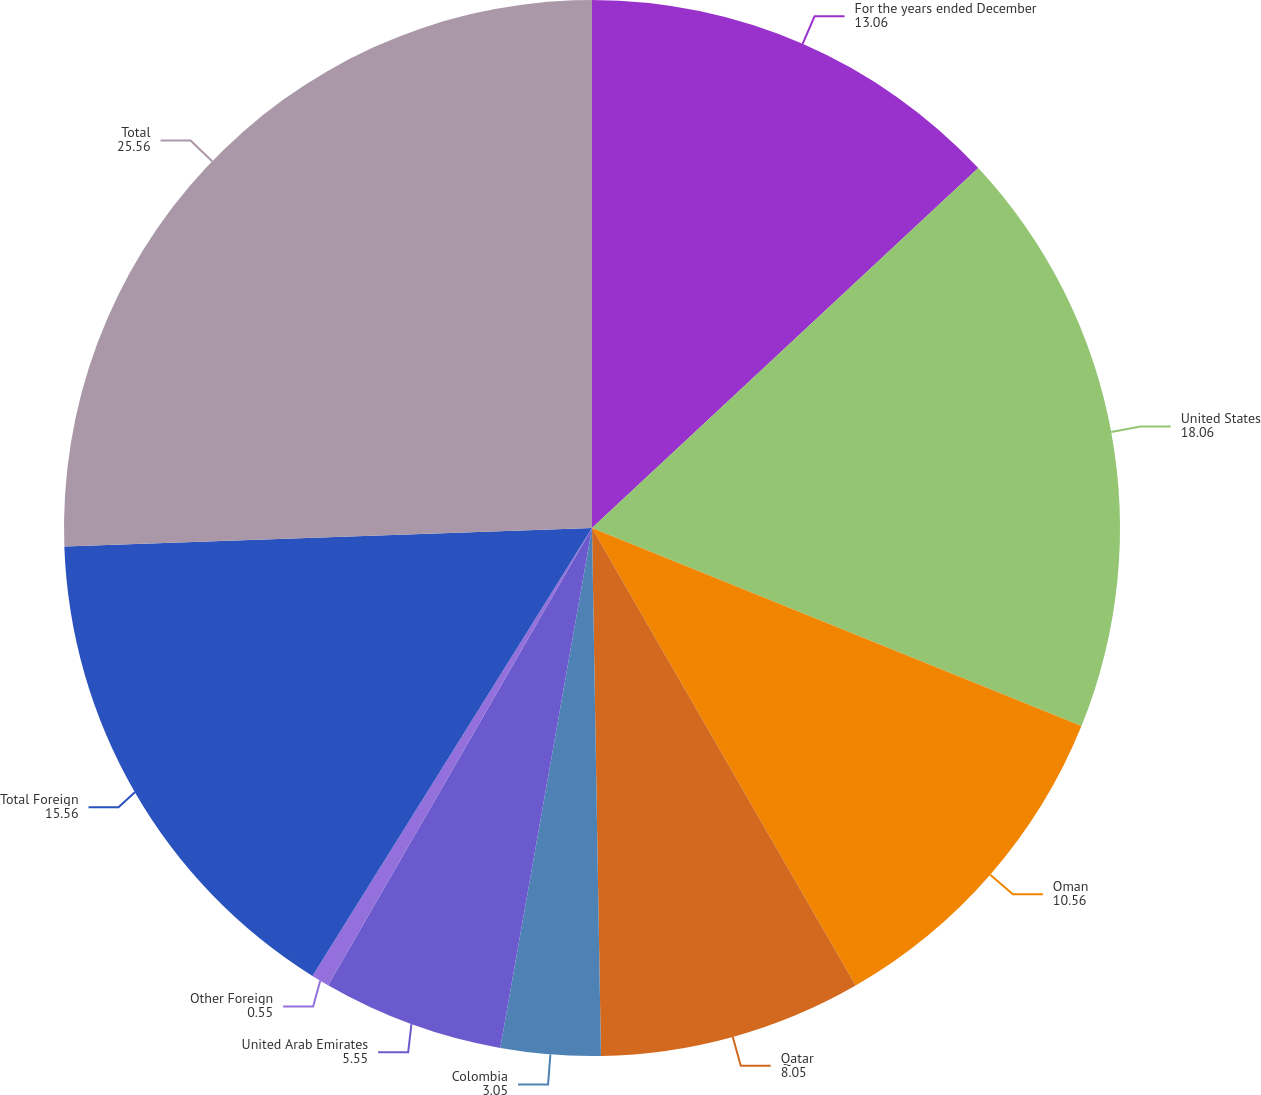<chart> <loc_0><loc_0><loc_500><loc_500><pie_chart><fcel>For the years ended December<fcel>United States<fcel>Oman<fcel>Qatar<fcel>Colombia<fcel>United Arab Emirates<fcel>Other Foreign<fcel>Total Foreign<fcel>Total<nl><fcel>13.06%<fcel>18.06%<fcel>10.56%<fcel>8.05%<fcel>3.05%<fcel>5.55%<fcel>0.55%<fcel>15.56%<fcel>25.56%<nl></chart> 